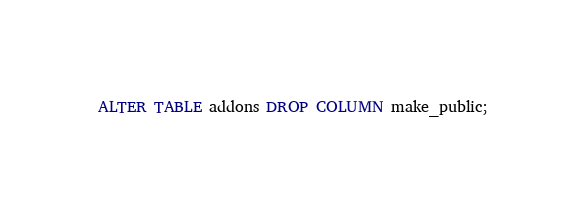Convert code to text. <code><loc_0><loc_0><loc_500><loc_500><_SQL_>ALTER TABLE addons DROP COLUMN make_public;
</code> 